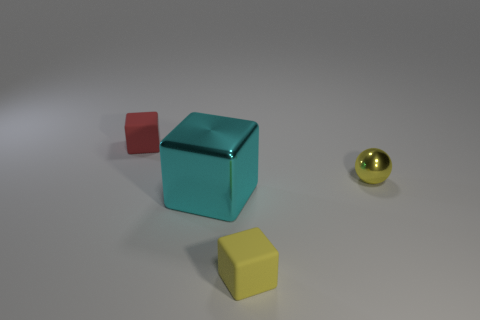Subtract all big cyan blocks. How many blocks are left? 2 Add 1 tiny yellow metal things. How many objects exist? 5 Subtract all tiny objects. Subtract all large cubes. How many objects are left? 0 Add 4 small balls. How many small balls are left? 5 Add 1 cyan shiny cubes. How many cyan shiny cubes exist? 2 Subtract all yellow blocks. How many blocks are left? 2 Subtract 0 blue balls. How many objects are left? 4 Subtract all blocks. How many objects are left? 1 Subtract all brown cubes. Subtract all blue cylinders. How many cubes are left? 3 Subtract all blue cylinders. How many purple spheres are left? 0 